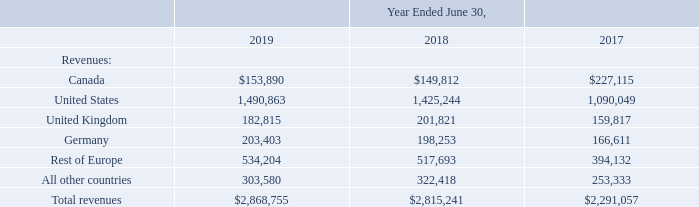NOTE 19—SEGMENT INFORMATION
ASC Topic 280, “Segment Reporting” (Topic 280), establishes standards for reporting, by public business enterprises, information about operating segments, products and services, geographic areas, and major customers. The method of determining what information, under Topic 280, to report is based on the way that an entity organizes operating segments for making operational decisions and how the entity’s management and chief operating decision maker (CODM) assess an entity’s financial performance. Our operations are analyzed by management and our CODM as being part of a single industry segment: the design, development, marketing and sales of Enterprise Information Management software and solutions.
The following table sets forth the distribution of revenues, by significant geographic area, for the periods indicated:
What does the table show? Distribution of revenues, by significant geographic area, for the periods indicated. What is the full form of CODM? Chief operating decision maker. What are the Fiscal years included in the table? 2019, 2018, 2017. What is the average annual Total revenue? (2,868,755+2,815,241+2,291,057)/3
Answer: 2658351. What is the difference between total revenue for fiscal year 2019 and 2018? 2,868,755-2,815,241
Answer: 53514. What is the increase in revenue for Canada from Fiscal year 2018 to 2019? 153,890-149,812
Answer: 4078. 